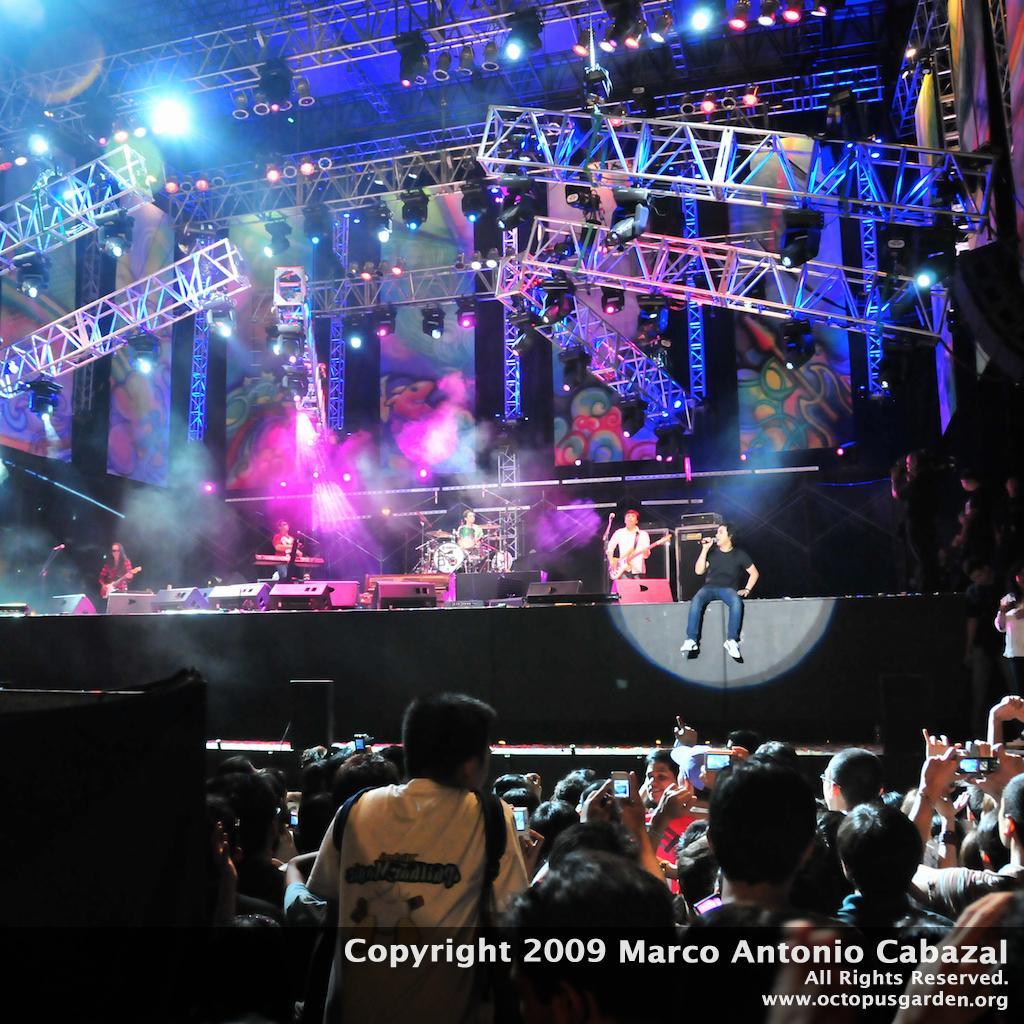Can you describe this image briefly? In the image I can see few people are standing and few people are holding something. I can see few people are holding musical instruments and one person is holding the mic. I can see few lights, speakers and the colorful background. 